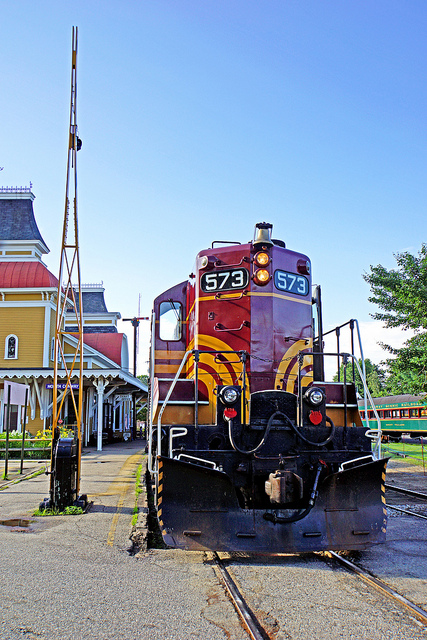Identify and read out the text in this image. 573 573 